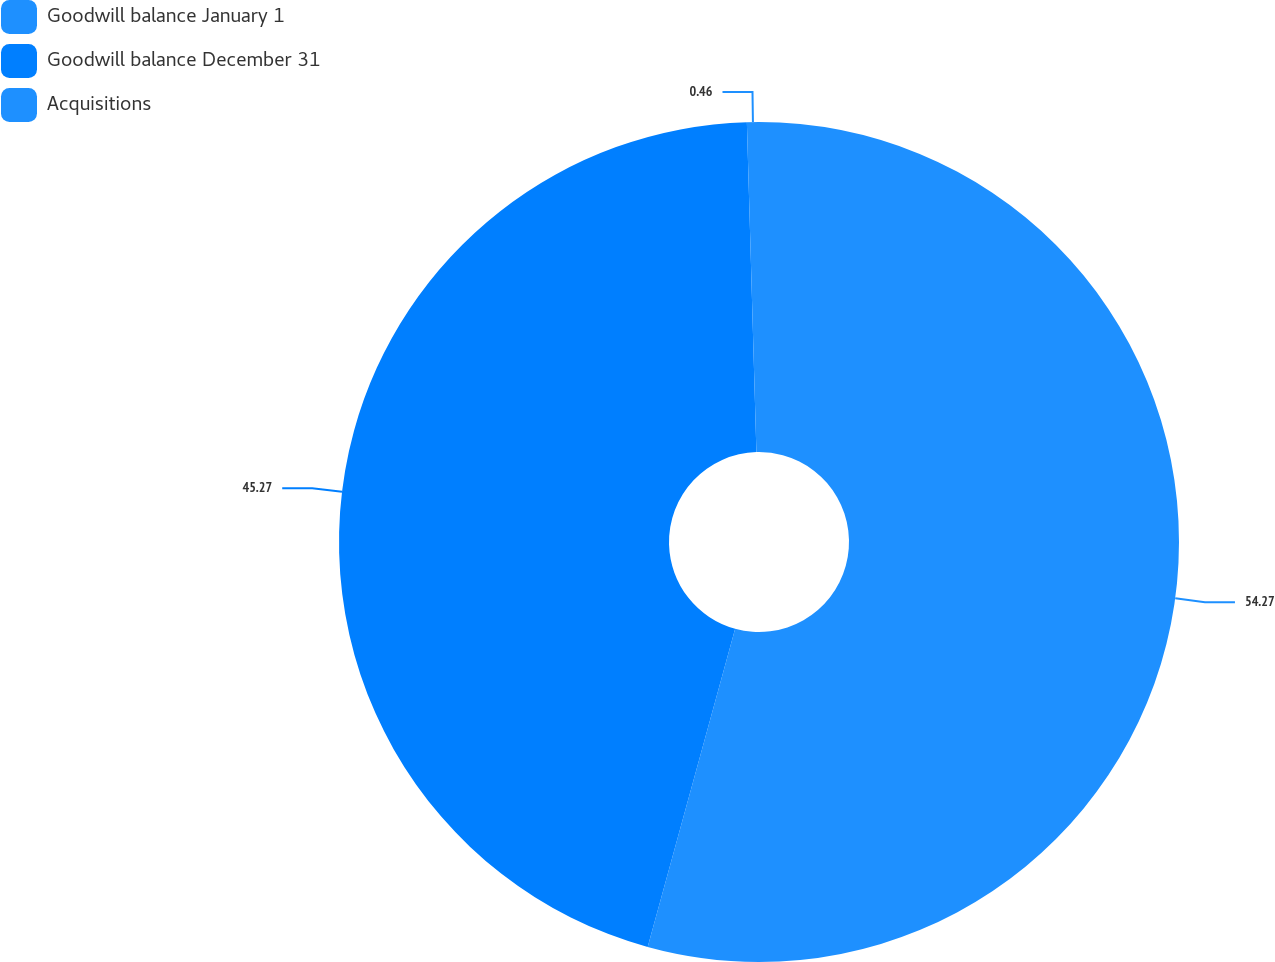Convert chart. <chart><loc_0><loc_0><loc_500><loc_500><pie_chart><fcel>Goodwill balance January 1<fcel>Goodwill balance December 31<fcel>Acquisitions<nl><fcel>54.27%<fcel>45.27%<fcel>0.46%<nl></chart> 